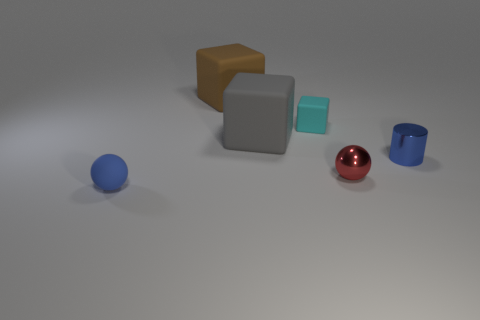Does the sphere that is to the right of the blue rubber sphere have the same size as the big brown rubber object? The red sphere to the right of the blue sphere is smaller in size compared to the large brown cube in the back. While the red sphere has a glossy finish that reflects light, making it appear prominent, it is not as large as the matte brown cube. 